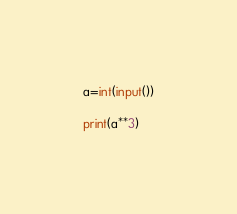<code> <loc_0><loc_0><loc_500><loc_500><_Python_>a=int(input())

print(a**3)</code> 